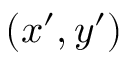Convert formula to latex. <formula><loc_0><loc_0><loc_500><loc_500>( x ^ { \prime } , y ^ { \prime } )</formula> 